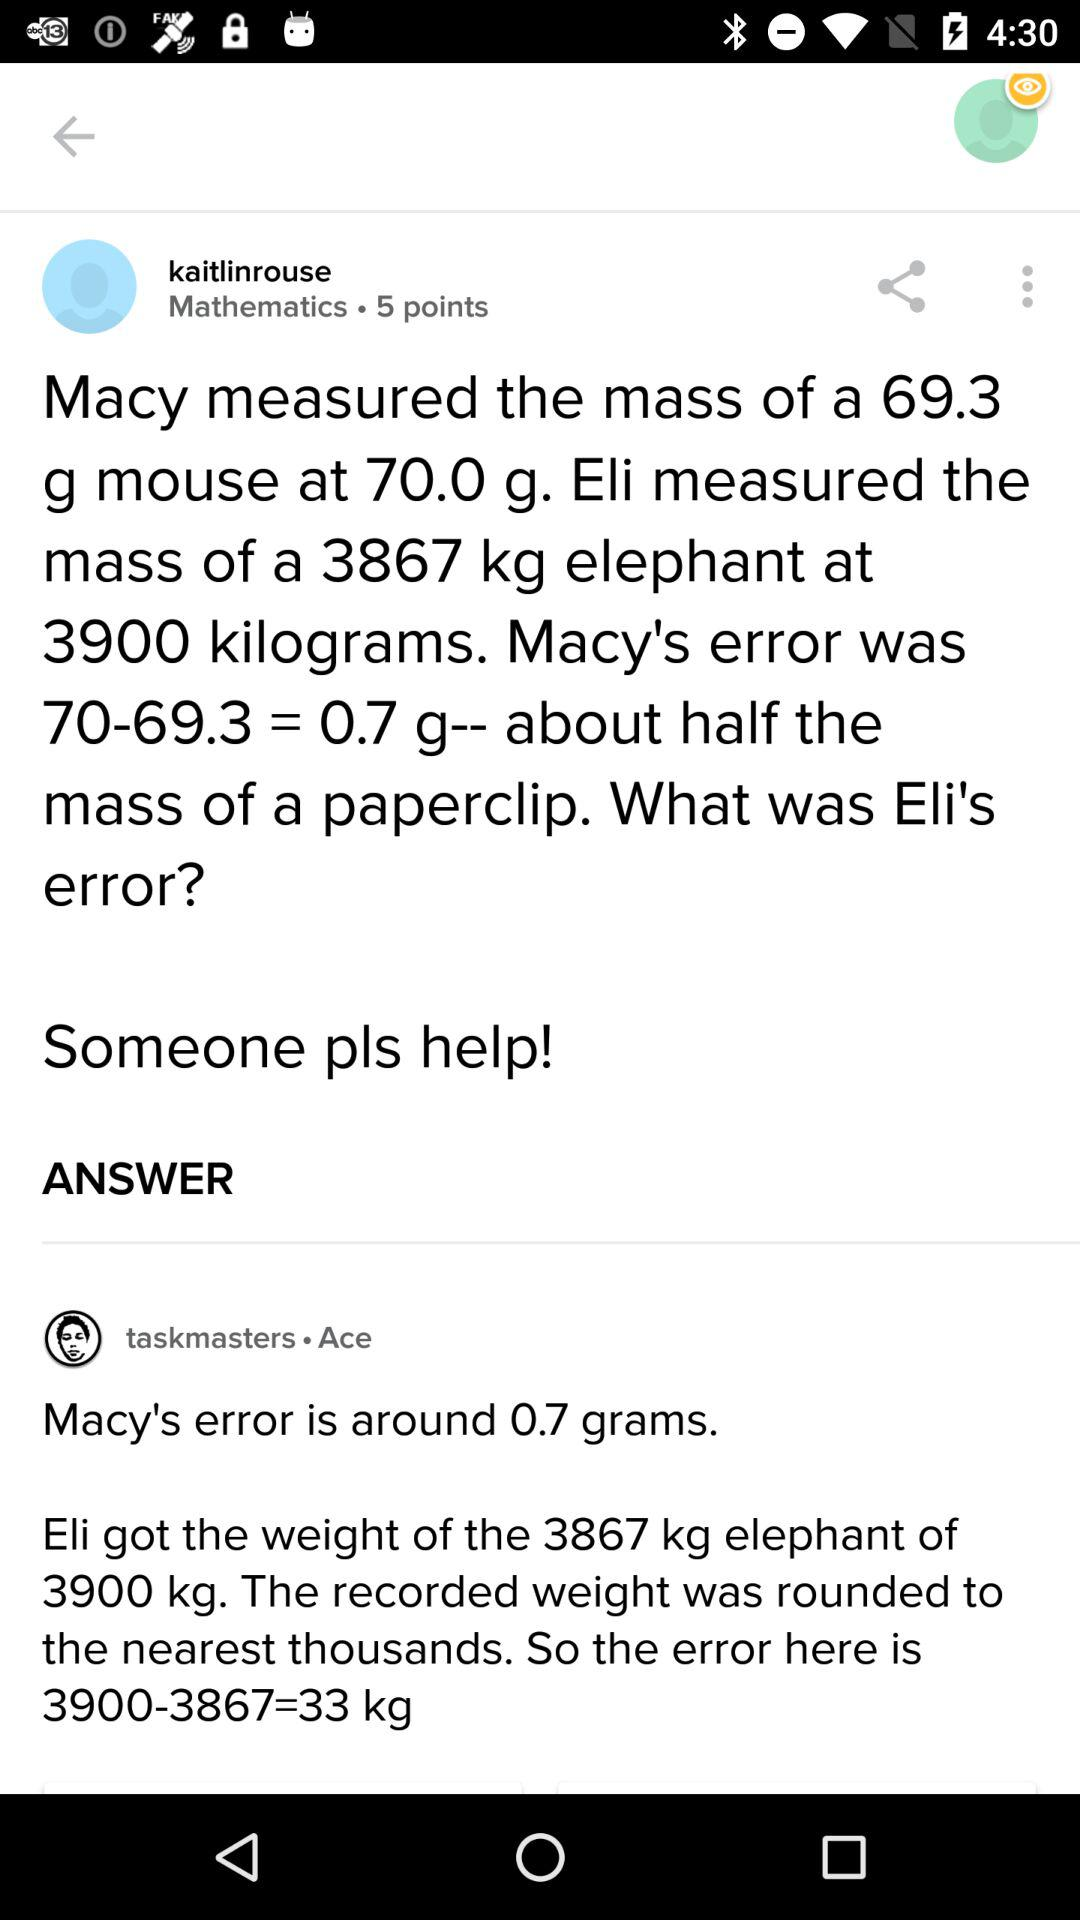How many points are given for mathematics? There are 5 points given for mathematics. 